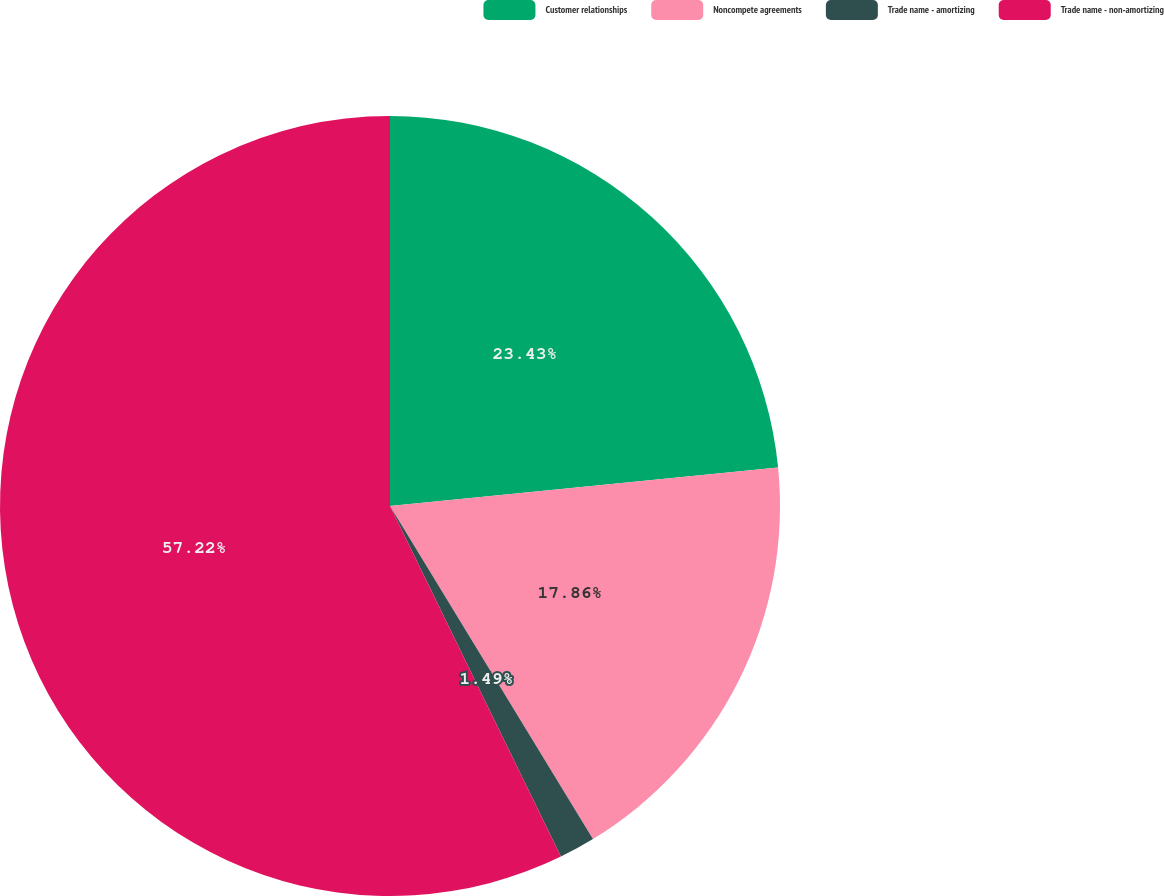<chart> <loc_0><loc_0><loc_500><loc_500><pie_chart><fcel>Customer relationships<fcel>Noncompete agreements<fcel>Trade name - amortizing<fcel>Trade name - non-amortizing<nl><fcel>23.43%<fcel>17.86%<fcel>1.49%<fcel>57.22%<nl></chart> 